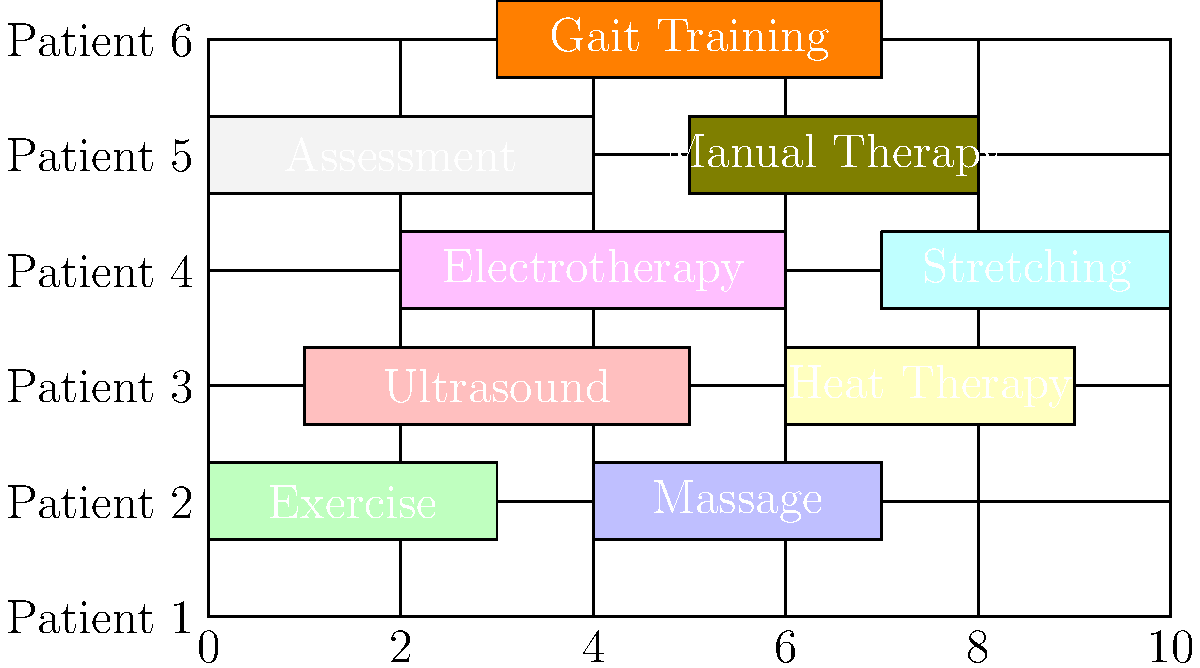Based on the Gantt chart showing patient appointments and therapy treatments, which two patients have overlapping treatments that use the same equipment, potentially causing a scheduling conflict? To identify patients with overlapping treatments that use the same equipment, we need to analyze the Gantt chart step-by-step:

1. Examine each patient's schedule:
   - Patient 1: Exercise (0-3 hours), Massage (4-7 hours)
   - Patient 2: Ultrasound (1-5 hours), Heat Therapy (6-9 hours)
   - Patient 3: Electrotherapy (2-6 hours), Stretching (7-10 hours)
   - Patient 4: Assessment (0-4 hours), Manual Therapy (5-8 hours)
   - Patient 5: Gait Training (3-7 hours)

2. Identify treatments that likely use specialized equipment:
   - Ultrasound
   - Electrotherapy
   - Heat Therapy

3. Look for overlaps in these treatments:
   - Patient 2's Ultrasound (1-5 hours) overlaps with Patient 3's Electrotherapy (2-6 hours)

4. Verify if these treatments use the same equipment:
   - While Ultrasound and Electrotherapy are different modalities, they often use similar electronic equipment or may be part of a combination therapy unit.

5. Conclude that Patients 2 and 3 have overlapping treatments (Ultrasound and Electrotherapy) from hours 2-5, which may require the same or similar equipment, potentially causing a scheduling conflict.
Answer: Patients 2 and 3 